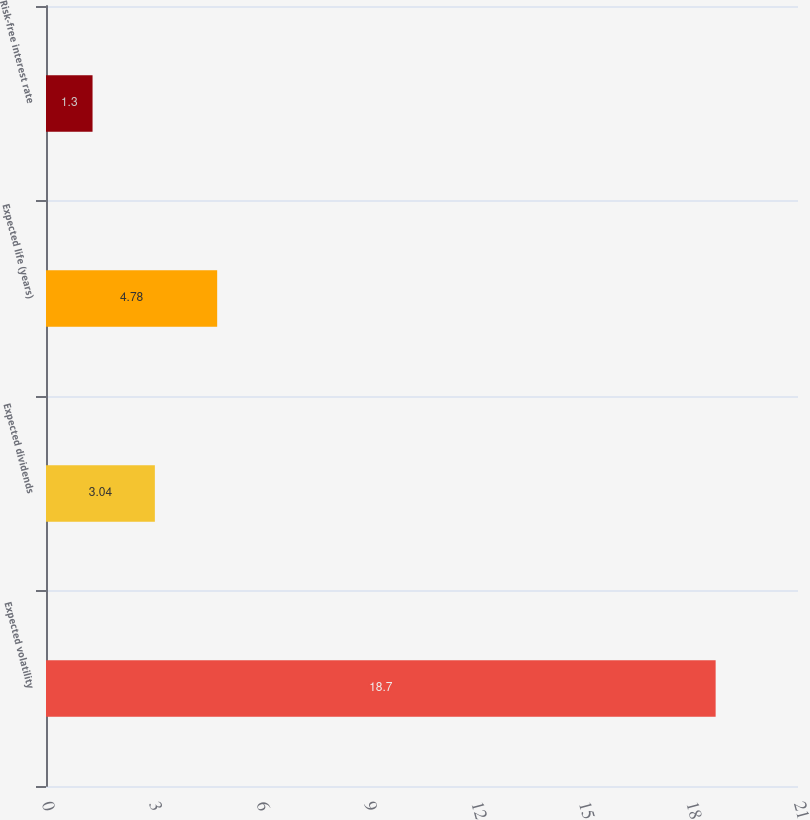Convert chart to OTSL. <chart><loc_0><loc_0><loc_500><loc_500><bar_chart><fcel>Expected volatility<fcel>Expected dividends<fcel>Expected life (years)<fcel>Risk-free interest rate<nl><fcel>18.7<fcel>3.04<fcel>4.78<fcel>1.3<nl></chart> 